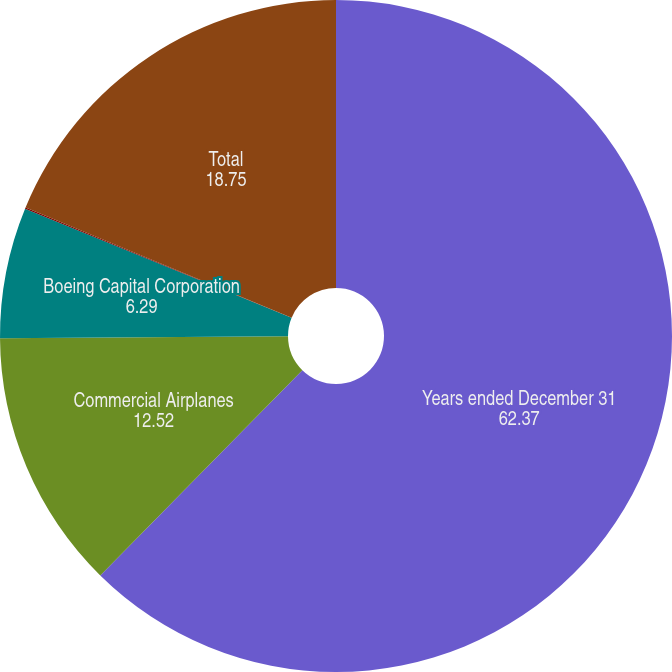Convert chart to OTSL. <chart><loc_0><loc_0><loc_500><loc_500><pie_chart><fcel>Years ended December 31<fcel>Commercial Airplanes<fcel>Boeing Capital Corporation<fcel>Other<fcel>Total<nl><fcel>62.37%<fcel>12.52%<fcel>6.29%<fcel>0.06%<fcel>18.75%<nl></chart> 